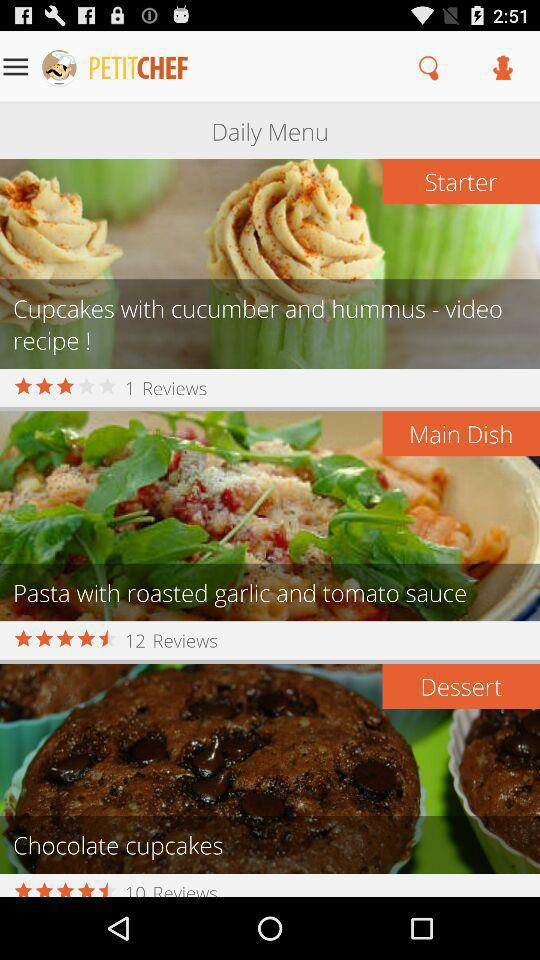What is the rating for the main dish? The rating is 4.5 stars. 